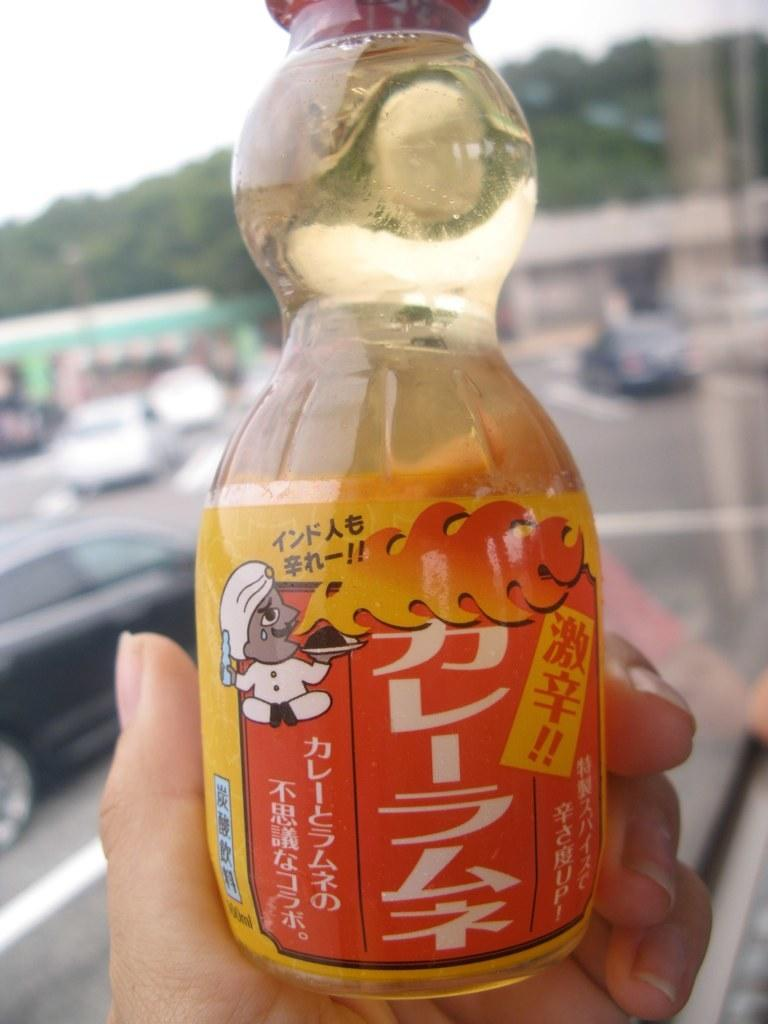What part of a person's body is visible in the image? There is a person's hand in the image. What is the person holding in their hand? The person is holding a bottle. What can be seen in the background of the image? There are cars visible on the road and trees in the background. How many rooms can be seen in the image? There is no room visible in the image; it only shows a person's hand holding a bottle and the background with cars and trees. 